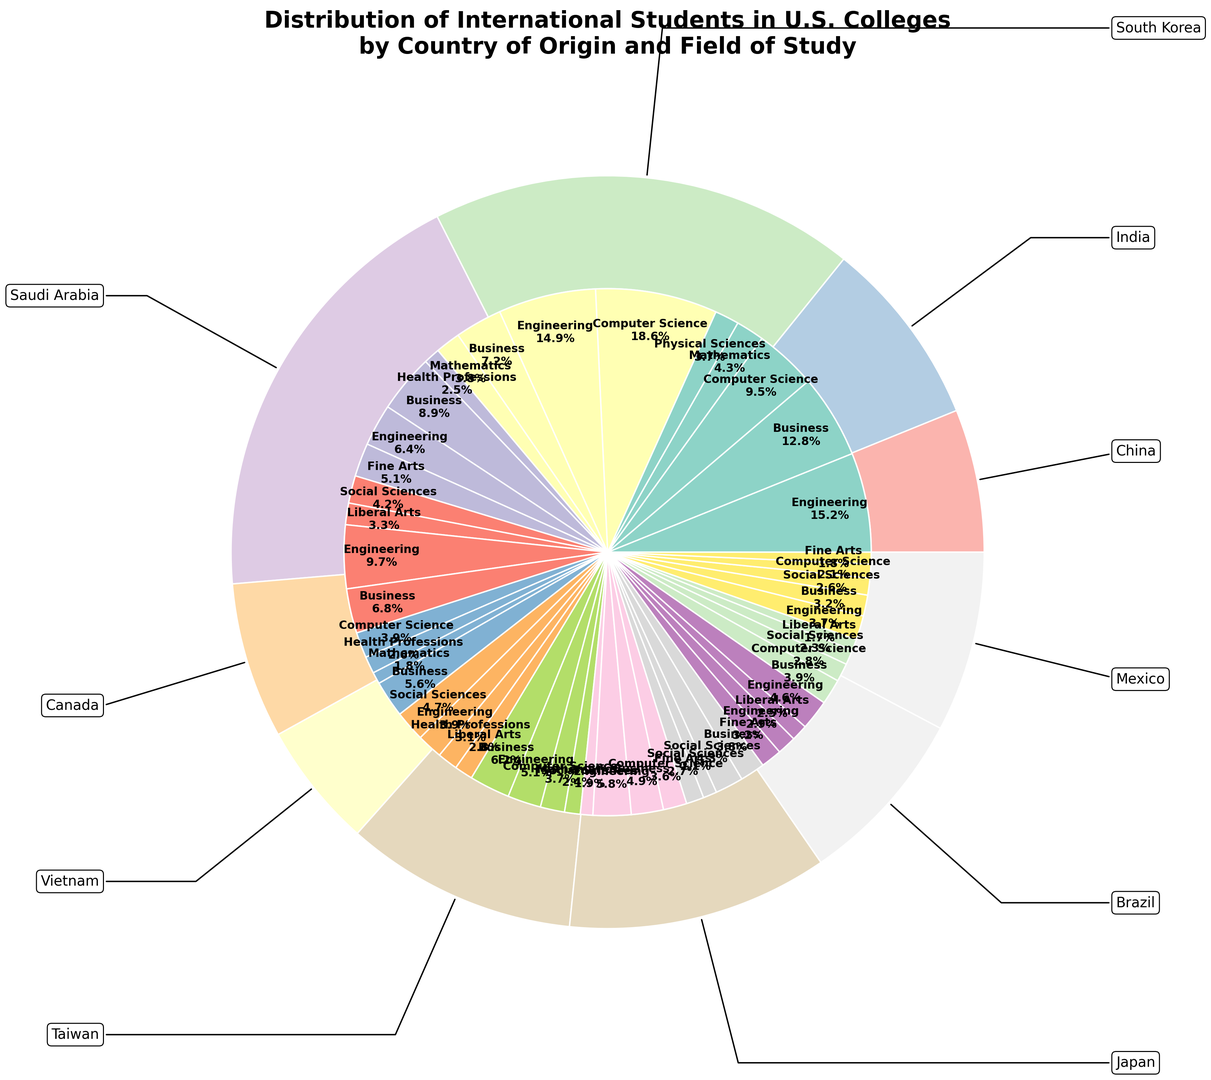What percentage of international students from China study Engineering and Computer Science combined? To find the combined percentage, add the percentages of Chinese students studying Engineering and Computer Science: 15.2% (Engineering) + 9.5% (Computer Science) = 24.7%.
Answer: 24.7% Which country has the highest proportion of students in Computer Science? From the inner pie chart, India's portion in Computer Science is the largest at 18.6%.
Answer: India Is the percentage of South Korean students studying Business larger or smaller than those studying Engineering? The percentage of South Korean students studying Business is 8.9%, which is larger compared to 6.4% for Engineering.
Answer: Larger Which field of study has the smallest percentage of students from Vietnam? For Vietnam, the smallest percentage shown in the inner pie chart is for Social Sciences at 1.9%.
Answer: Social Sciences What is the combined percentage of students from Saudi Arabia studying Health Professions and Mathematics? The sum of the percentages is 2.6% (Health Professions) + 1.8% (Mathematics) = 4.4%.
Answer: 4.4% Which country has the smallest overall proportion of international students? Based on the outer ring, Mexico has the smallest proportion.
Answer: Mexico How much larger is the percentage of Indian students studying Engineering compared to Mexican students studying Engineering? Calculate the difference: 14.9% (India) - 3.7% (Mexico) = 11.2%.
Answer: 11.2% Do more Taiwanese students study Business or Engineering, and by how much? Taiwanese students in Business are 4.9% and in Engineering are 5.8%, so more study Engineering. The difference is 5.8% - 4.9% = 0.9%.
Answer: Engineering, 0.9% Which three countries have the highest percentages of students in Business? The top three are China (12.8%), India (7.2%), and South Korea (8.9%).
Answer: China, South Korea, India 